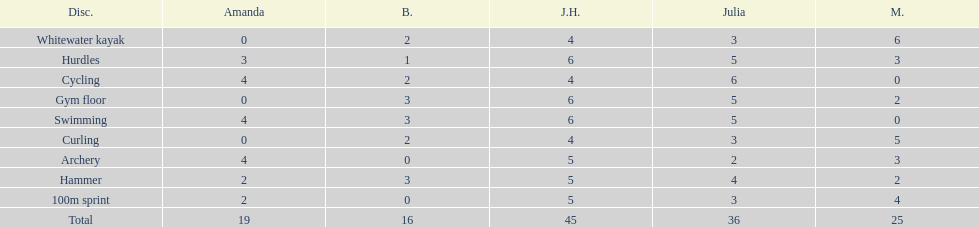What is the first discipline listed on this chart? Whitewater kayak. 